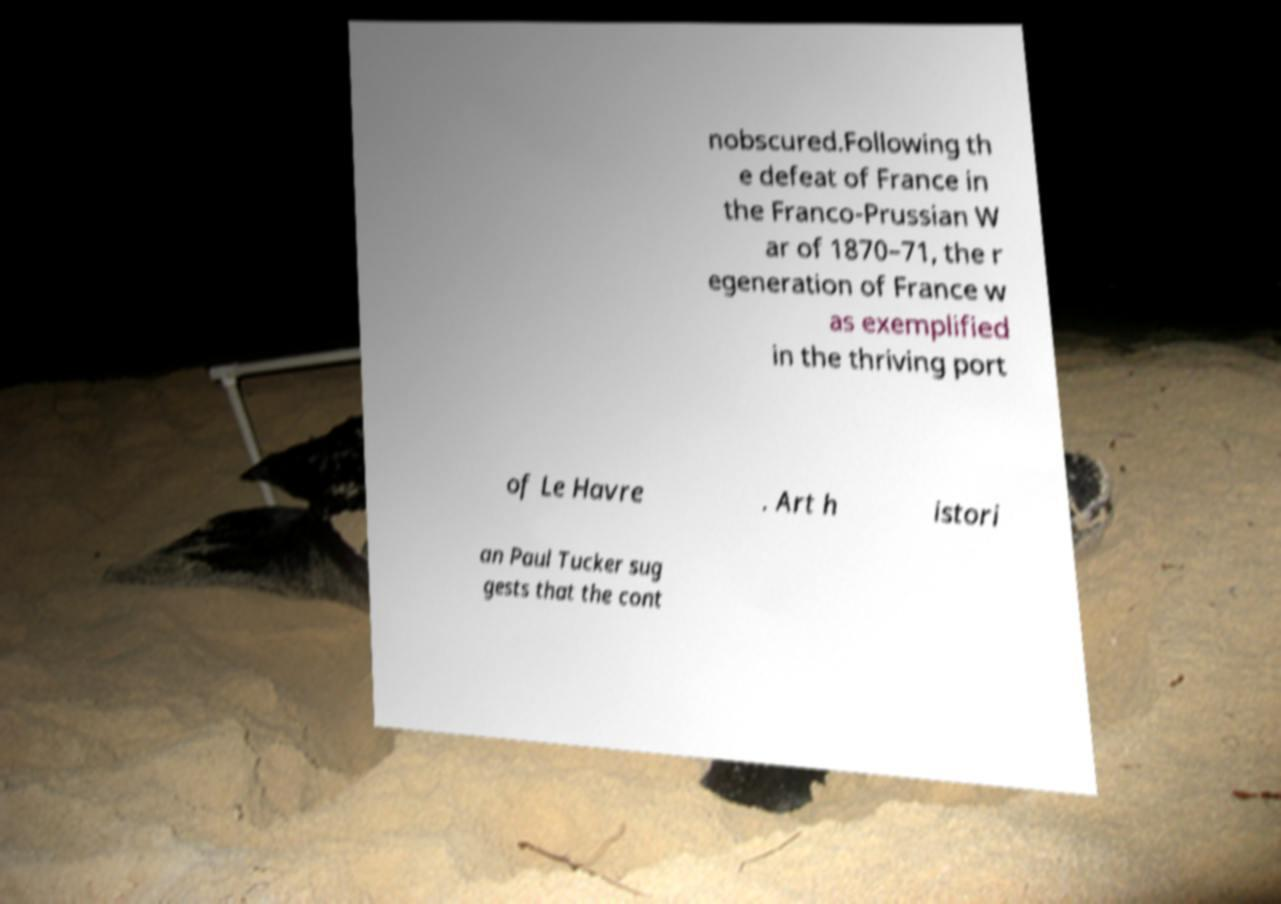For documentation purposes, I need the text within this image transcribed. Could you provide that? nobscured.Following th e defeat of France in the Franco-Prussian W ar of 1870–71, the r egeneration of France w as exemplified in the thriving port of Le Havre . Art h istori an Paul Tucker sug gests that the cont 